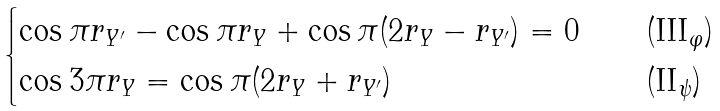Convert formula to latex. <formula><loc_0><loc_0><loc_500><loc_500>\begin{cases} \cos \pi r _ { Y ^ { \prime } } - \cos \pi r _ { Y } + \cos \pi ( 2 r _ { Y } - r _ { Y ^ { \prime } } ) = 0 & \quad ( \text {III} _ { \varphi } ) \\ \cos 3 \pi r _ { Y } = \cos \pi ( 2 r _ { Y } + r _ { Y ^ { \prime } } ) & \quad ( \text {II} _ { \psi } ) \end{cases}</formula> 